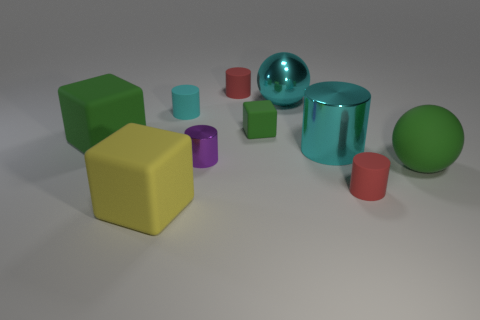Subtract 1 cylinders. How many cylinders are left? 4 Subtract all green blocks. Subtract all yellow cylinders. How many blocks are left? 1 Subtract all balls. How many objects are left? 8 Subtract 0 brown cylinders. How many objects are left? 10 Subtract all purple cylinders. Subtract all shiny spheres. How many objects are left? 8 Add 6 large green cubes. How many large green cubes are left? 7 Add 4 large purple shiny blocks. How many large purple shiny blocks exist? 4 